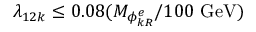Convert formula to latex. <formula><loc_0><loc_0><loc_500><loc_500>\lambda _ { 1 2 k } \leq 0 . 0 8 ( M _ { \phi _ { k R } ^ { e } } / 1 0 0 \ G e V )</formula> 